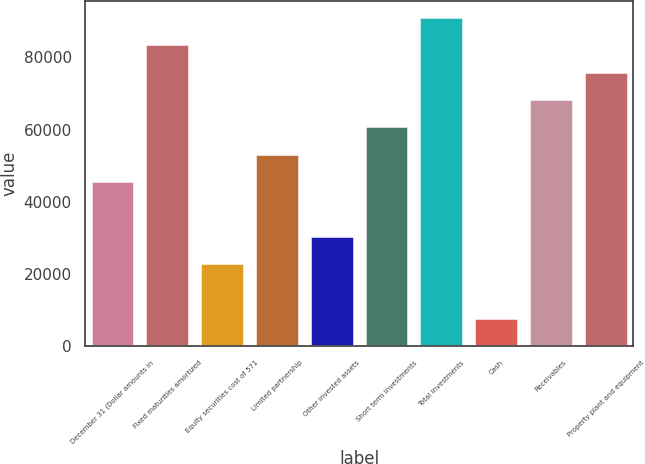<chart> <loc_0><loc_0><loc_500><loc_500><bar_chart><fcel>December 31 (Dollar amounts in<fcel>Fixed maturities amortized<fcel>Equity securities cost of 571<fcel>Limited partnership<fcel>Other invested assets<fcel>Short term investments<fcel>Total investments<fcel>Cash<fcel>Receivables<fcel>Property plant and equipment<nl><fcel>45744<fcel>83571.5<fcel>23047.5<fcel>53309.5<fcel>30613<fcel>60875<fcel>91137<fcel>7916.5<fcel>68440.5<fcel>76006<nl></chart> 